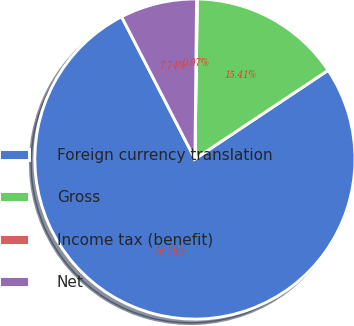Convert chart. <chart><loc_0><loc_0><loc_500><loc_500><pie_chart><fcel>Foreign currency translation<fcel>Gross<fcel>Income tax (benefit)<fcel>Net<nl><fcel>76.77%<fcel>15.41%<fcel>0.07%<fcel>7.74%<nl></chart> 